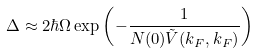<formula> <loc_0><loc_0><loc_500><loc_500>\Delta \approx 2 \hbar { \Omega } \exp \left ( - \frac { 1 } { N ( 0 ) \tilde { V } ( k _ { F } , k _ { F } ) } \right )</formula> 